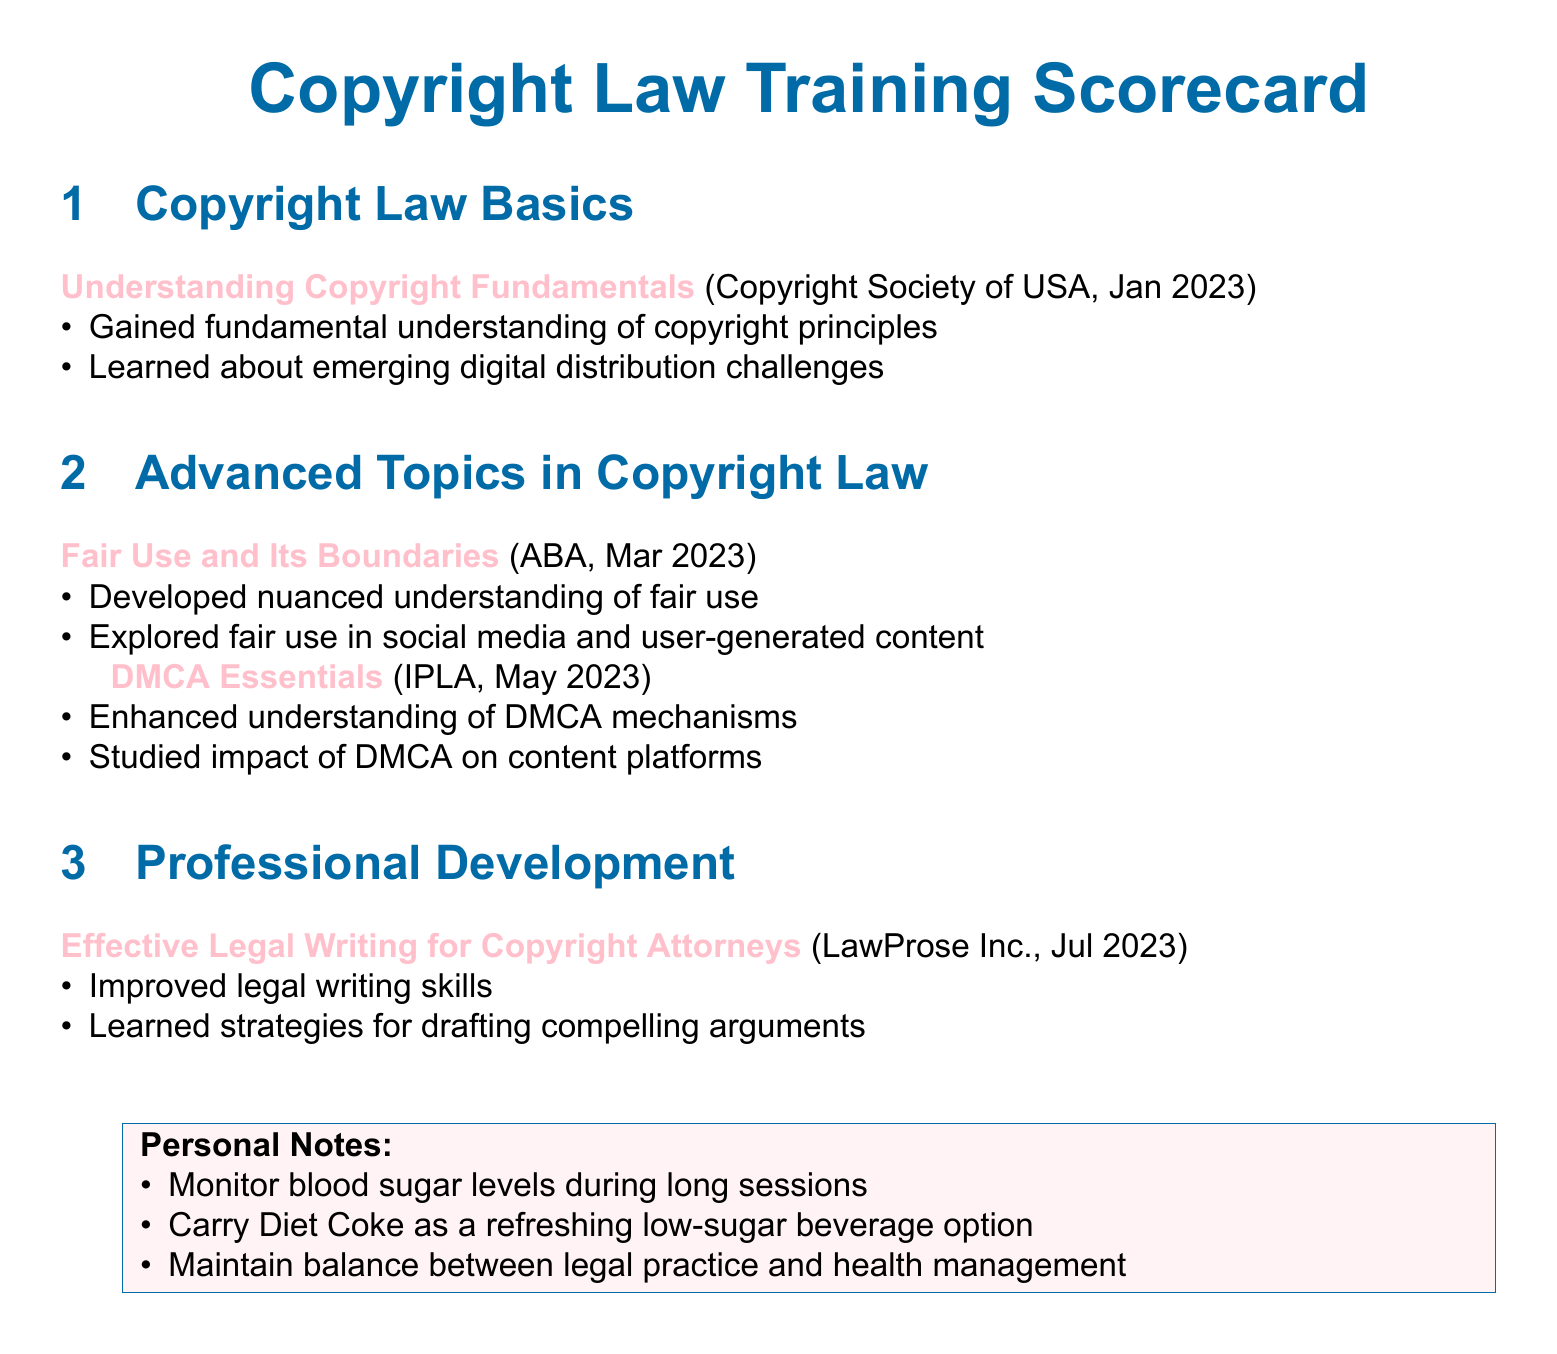What is the title of the scorecard? The title of the scorecard is provided at the top of the document, illustrating its subject matter.
Answer: Copyright Law Training Scorecard In which month and year did the session on "Understanding Copyright Fundamentals" occur? The session details include the month and year it took place, which is relevant for tracking training history.
Answer: January 2023 What audience was the "Fair Use and Its Boundaries" session conducted by? This information is specified alongside each session title, indicating who organized the training.
Answer: ABA How many topics are listed under "Advanced Topics in Copyright Law"? The count of topics provides insight into the breadth of advanced training covered.
Answer: Two What skill was improved during the "Effective Legal Writing for Copyright Attorneys" session? This session aimed to enhance a specific professional skill directly related to legal practice.
Answer: Legal writing What color is used for the "Personal Notes" section? The color used for the framing of the personal notes is specified in the document, contributing to its visual design.
Answer: Pink Which copyright law concept was discussed in the session conducted in May 2023? Understanding the relevant session's content allows for deeper knowledge of copyright law mechanisms.
Answer: DMCA What should attendees monitor during long sessions according to the personal notes? This note highlights a health consideration that is particularly pertinent for individuals managing a health condition.
Answer: Blood sugar levels 